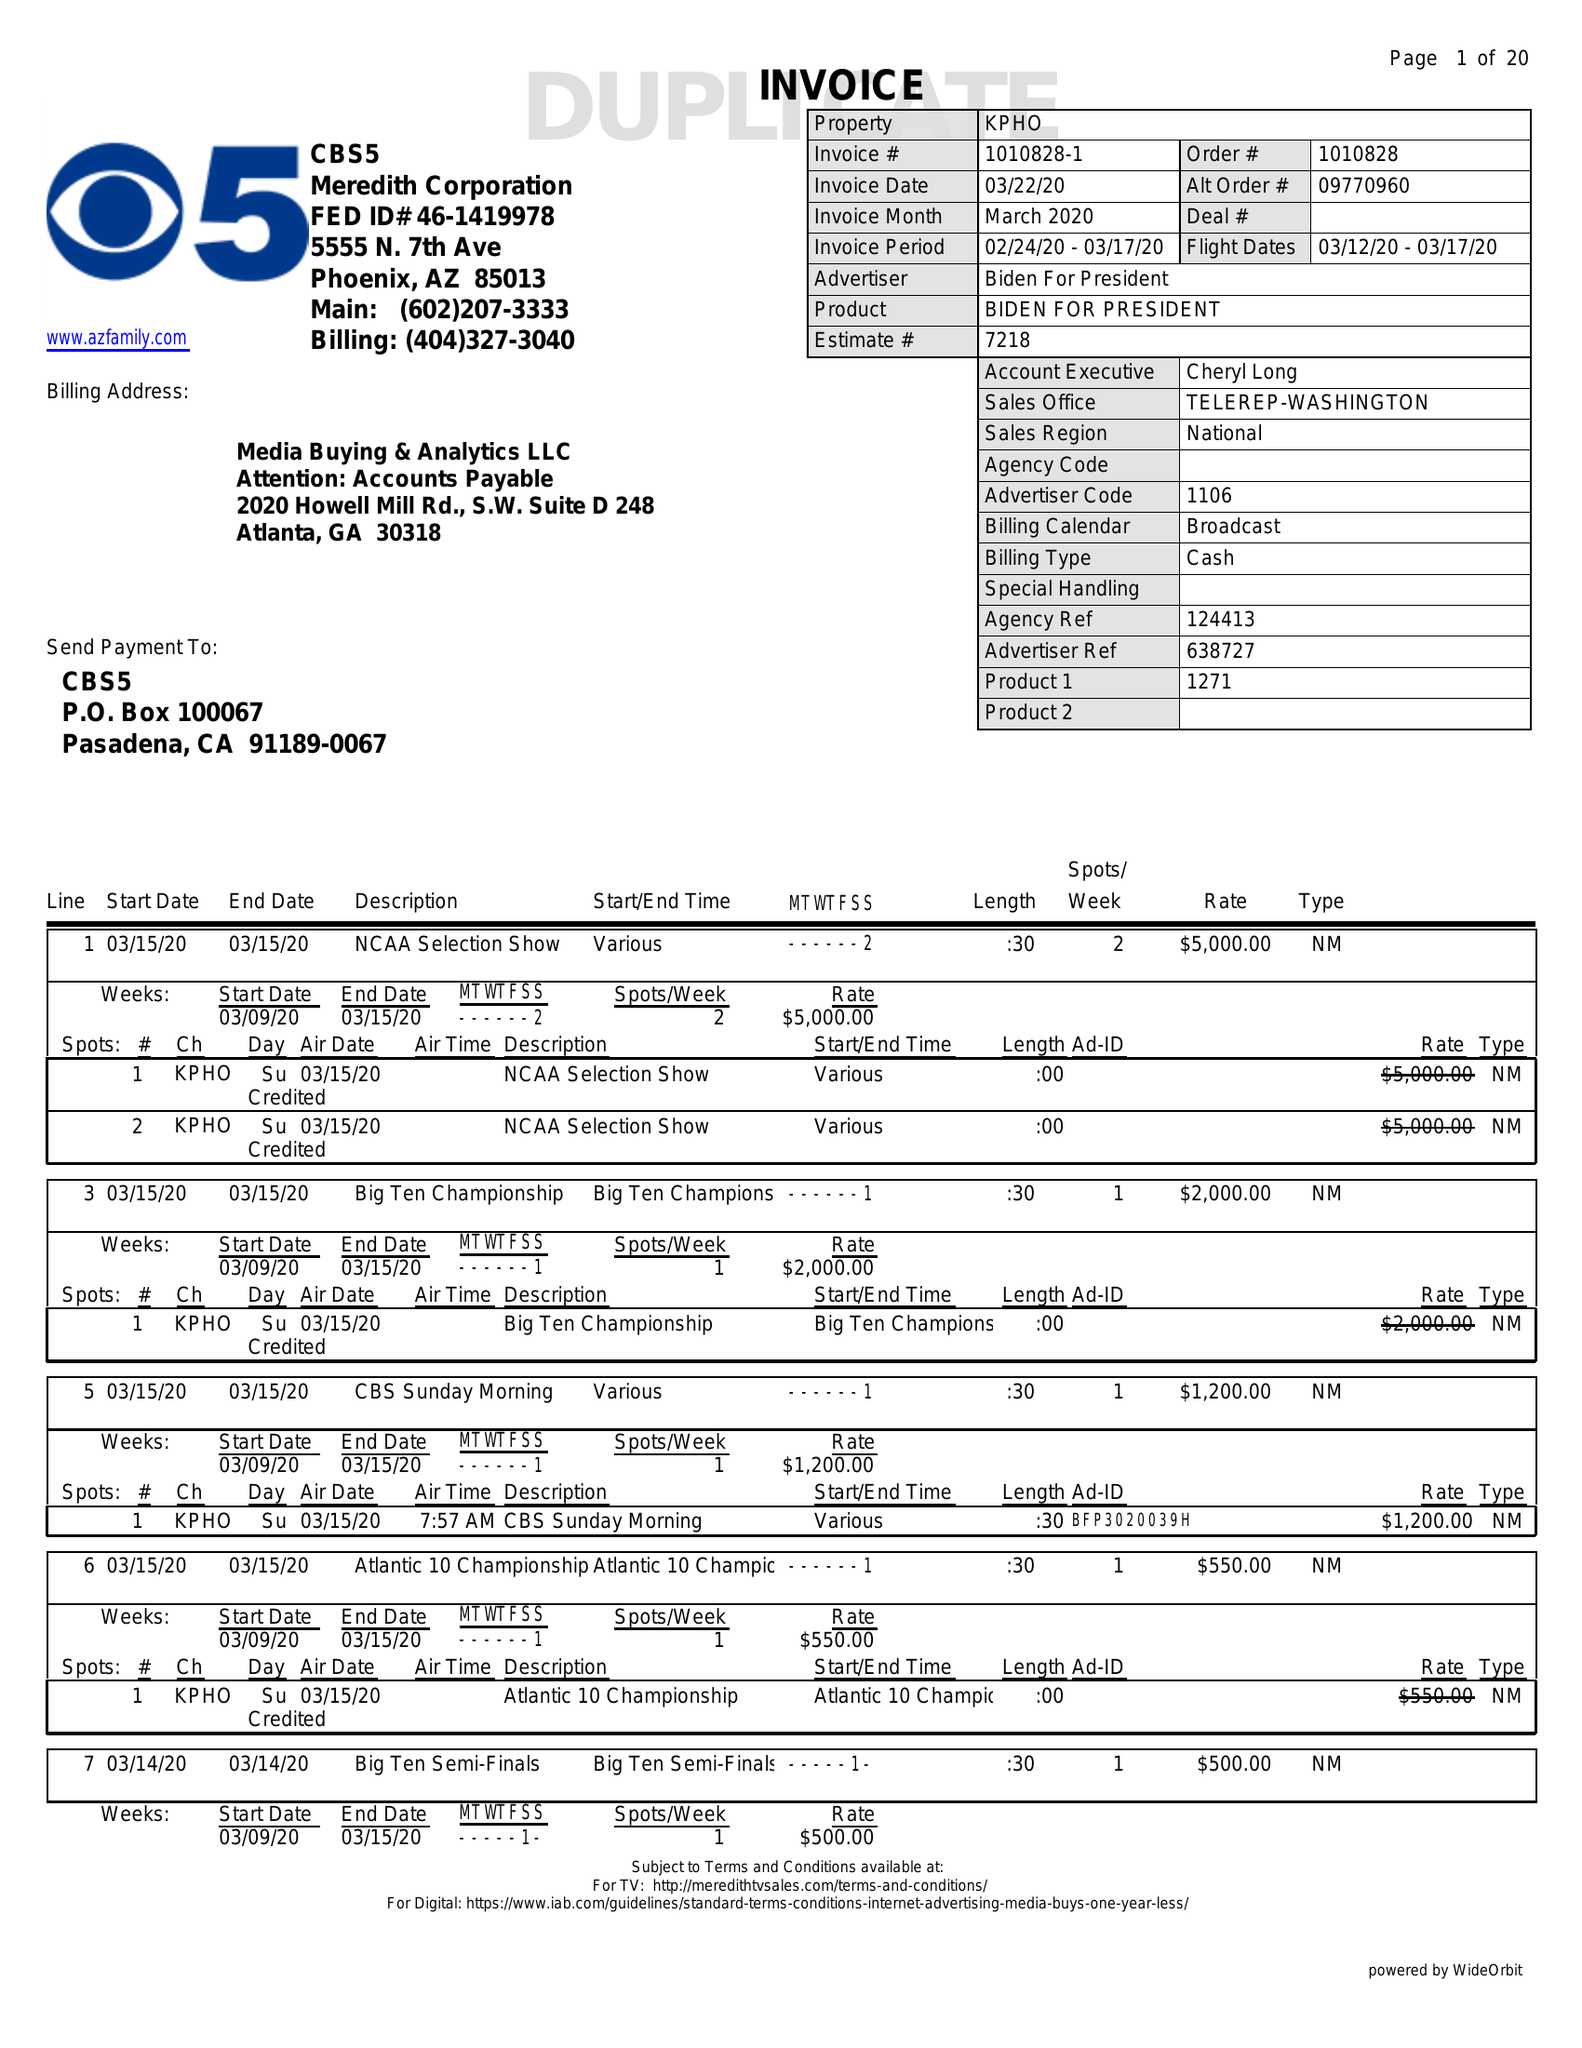What is the value for the flight_from?
Answer the question using a single word or phrase. 03/12/20 